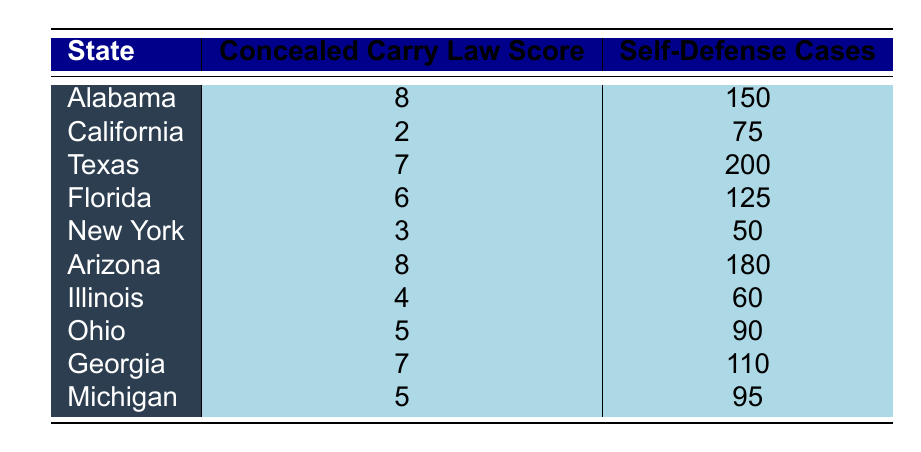What is the concealed carry law score for Texas? According to the table, Texas has a concealed carry law score of 7.
Answer: 7 Which state has the highest number of self-defense cases? By examining the self-defense cases column, Texas has the highest number with 200 cases.
Answer: Texas What is the average concealed carry law score of the listed states? To find the average, sum the concealed carry law scores (8 + 2 + 7 + 6 + 3 + 8 + 4 + 5 + 7 + 5 = 55) and then divide by the number of states (10). So the average score is 55/10 = 5.5.
Answer: 5.5 Is it true that California has more self-defense cases than Ohio? Looking at the table, California has 75 self-defense cases, while Ohio has 90 cases, meaning California has fewer. Thus, the statement is false.
Answer: No What is the difference in self-defense cases between Alabama and Georgia? Alabama has 150 self-defense cases and Georgia has 110. The difference is 150 - 110 = 40 cases.
Answer: 40 Which state or states have the same concealed carry law score as Florida? Florida has a concealed carry law score of 6. By checking the table, no other state shares this score, making Florida the only one with this score.
Answer: Florida Is there a direct correlation between concealed carry law scores and self-defense cases based on the provided data? To evaluate correlation, we need to look at the trends: states with higher scores (like Alabama and Arizona) tend to have higher self-defense cases compared to those with lower scores (like California and New York). Thus, there appears to be a positive correlation.
Answer: Yes What is the total number of self-defense cases in the states with a concealed carry law score of 8? The states with a score of 8 are Alabama (150 cases) and Arizona (180 cases). Adding these gives 150 + 180 = 330 cases.
Answer: 330 How many states have a concealed carry law score of 5 or higher? The states with a score of 5 or higher are Alabama, Texas, Florida, Arizona, Georgia, and Michigan (totaling 6 states).
Answer: 6 